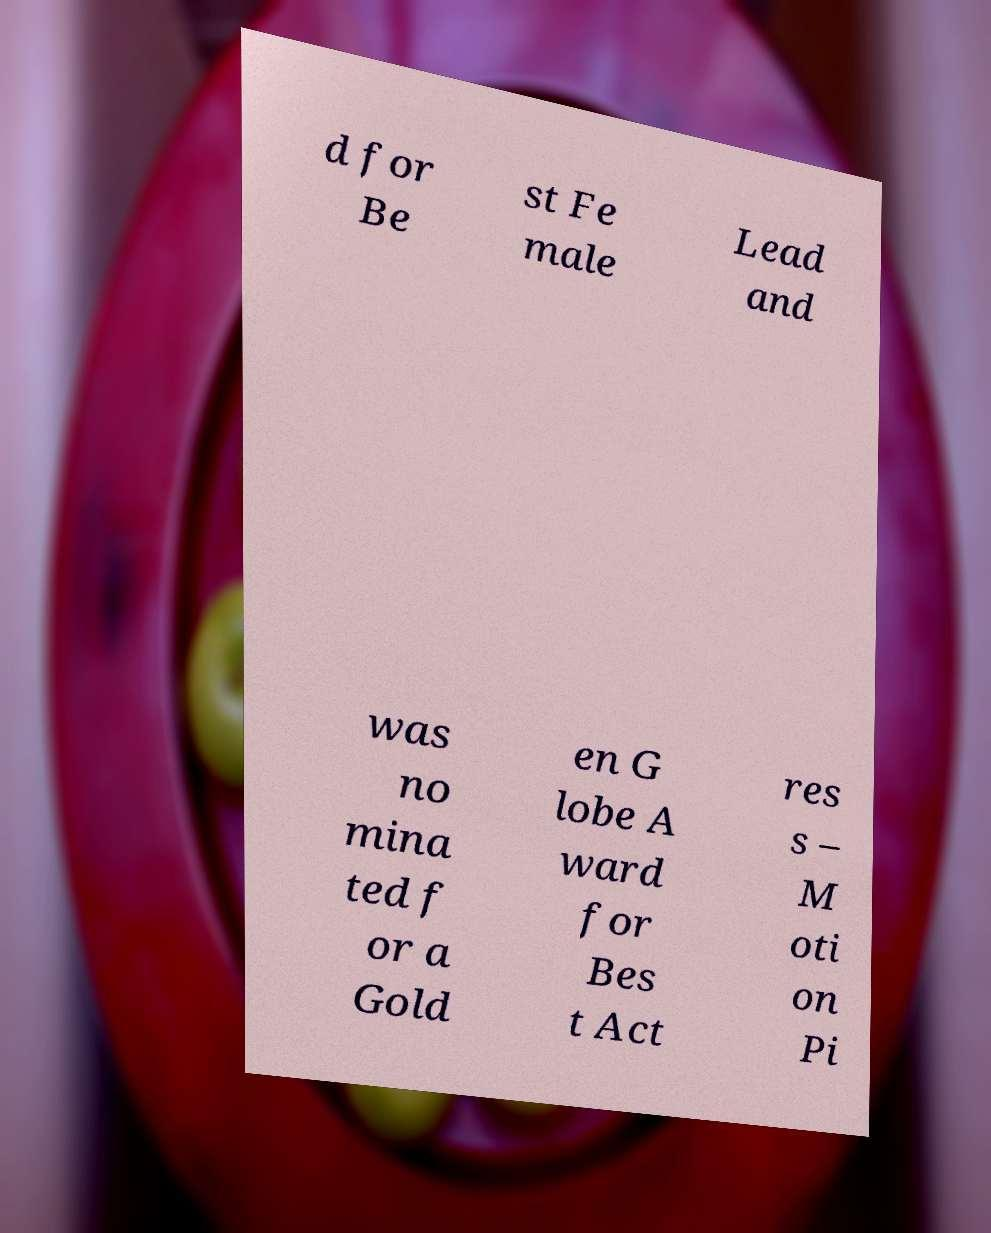Could you extract and type out the text from this image? d for Be st Fe male Lead and was no mina ted f or a Gold en G lobe A ward for Bes t Act res s – M oti on Pi 